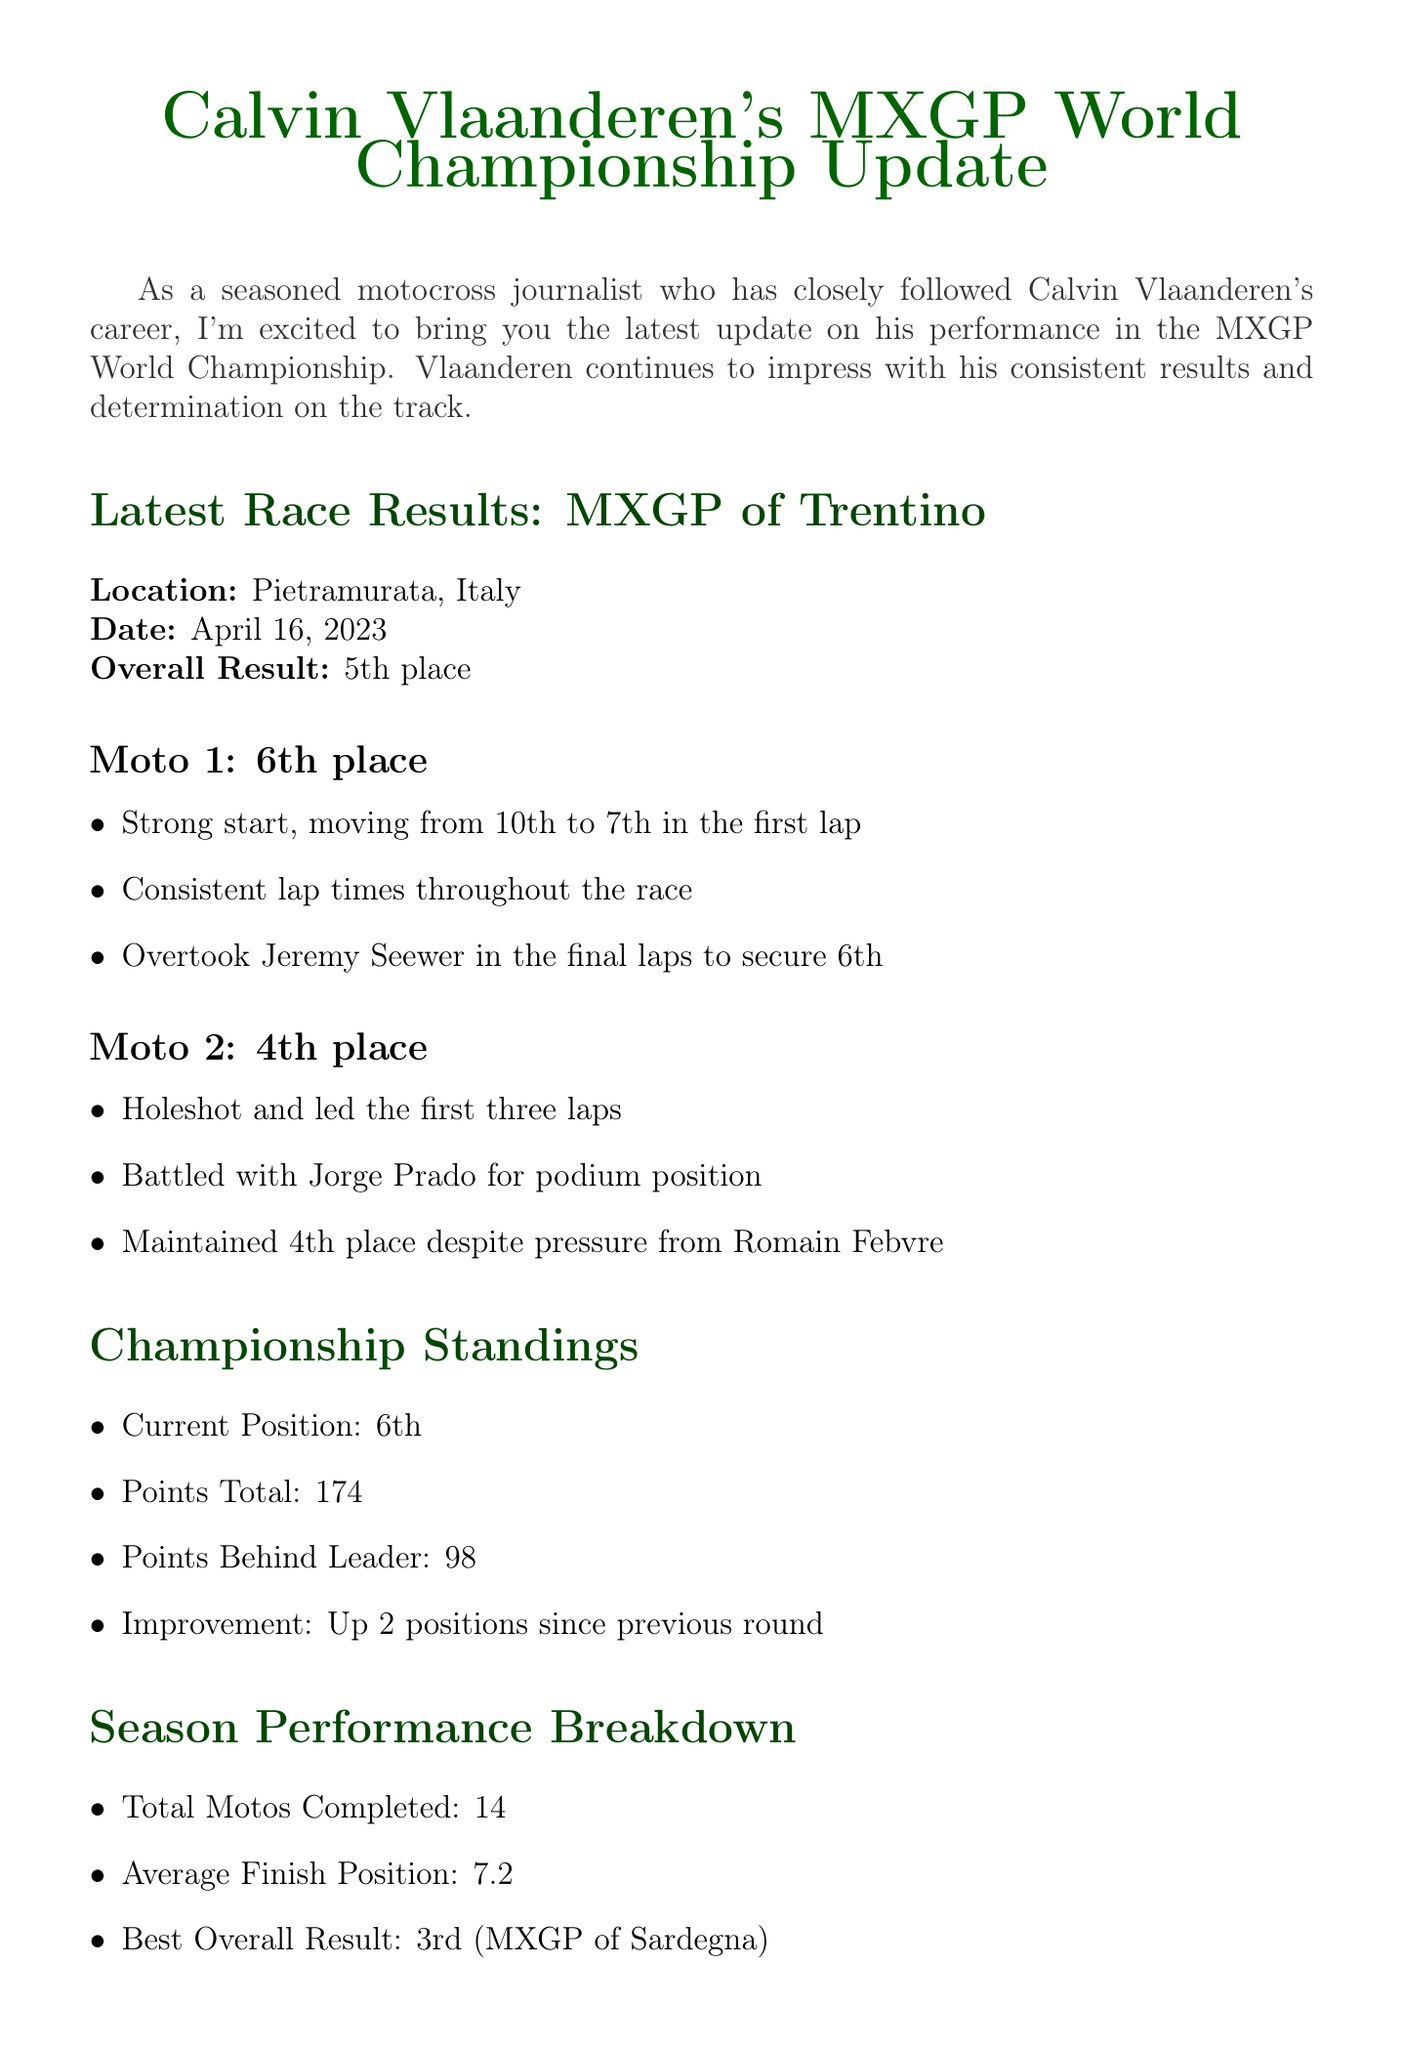What is Calvin Vlaanderen's overall result in the latest race? The latest race result shows that he finished in 5th place overall at the MXGP of Trentino.
Answer: 5th place In which location did the recent race take place? The recent race took place in Pietramurata, Italy.
Answer: Pietramurata, Italy What was Vlaanderen's position in Moto 1? In Moto 1, he secured 6th place according to the race results.
Answer: 6th How many total points does Vlaanderen have in the championship standings? The document states that he has a total of 174 points in the championship standings.
Answer: 174 What are the upcoming race date and location? The upcoming race is scheduled for April 30, 2023, in intu Xanadú – Arroyomolinos.
Answer: April 30, 2023, intu Xanadú – Arroyomolinos What has been noted as an area for improvement for Vlaanderen this season? The document indicates that maintaining lead positions under pressure is an area for improvement for Vlaanderen.
Answer: Maintaining lead positions under pressure What did Vlaanderen lead for three laps in Moto 2? In Moto 2, he had the holeshot and led the first three laps of the race.
Answer: holeshot How many holeshots has Vlaanderen achieved this season? The document mentions that he has achieved a total of 3 holeshots this season.
Answer: 3 What improvement is noted in the championship standings since the previous round? Vlaanderen has improved by 2 positions since the previous round in the championship standings.
Answer: Up 2 positions since previous round What is Vlaanderen's best overall result this season? His best overall result this season was 3rd place at the MXGP of Sardegna.
Answer: 3rd 